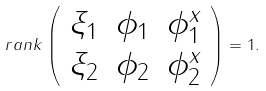Convert formula to latex. <formula><loc_0><loc_0><loc_500><loc_500>\ r a n k \left ( \begin{array} { c c c } \xi _ { 1 } & \phi _ { 1 } & \phi _ { 1 } ^ { x } \\ \xi _ { 2 } & \phi _ { 2 } & \phi _ { 2 } ^ { x } \end{array} \right ) = 1 .</formula> 